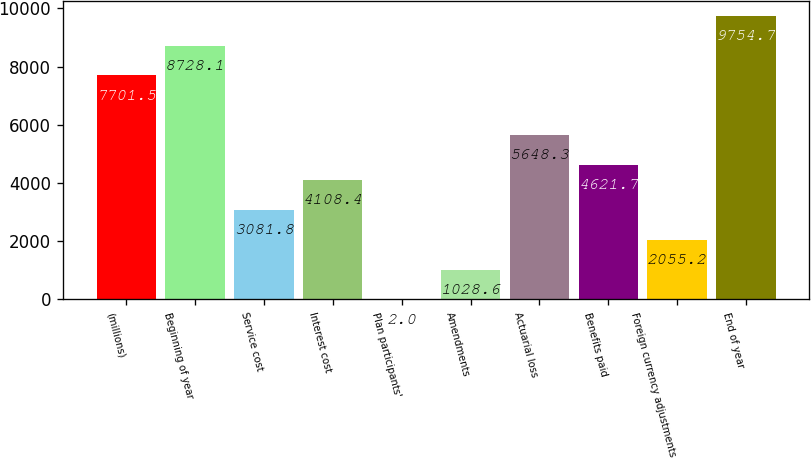Convert chart. <chart><loc_0><loc_0><loc_500><loc_500><bar_chart><fcel>(millions)<fcel>Beginning of year<fcel>Service cost<fcel>Interest cost<fcel>Plan participants'<fcel>Amendments<fcel>Actuarial loss<fcel>Benefits paid<fcel>Foreign currency adjustments<fcel>End of year<nl><fcel>7701.5<fcel>8728.1<fcel>3081.8<fcel>4108.4<fcel>2<fcel>1028.6<fcel>5648.3<fcel>4621.7<fcel>2055.2<fcel>9754.7<nl></chart> 